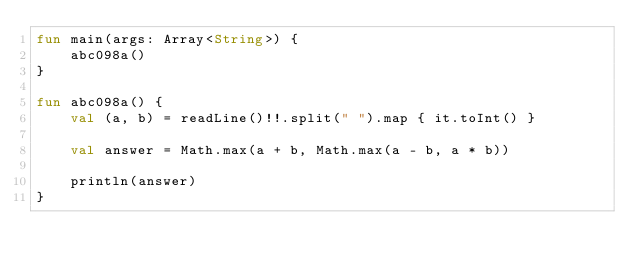<code> <loc_0><loc_0><loc_500><loc_500><_Kotlin_>fun main(args: Array<String>) {
    abc098a()
}

fun abc098a() {
    val (a, b) = readLine()!!.split(" ").map { it.toInt() }

    val answer = Math.max(a + b, Math.max(a - b, a * b))

    println(answer)
}
</code> 